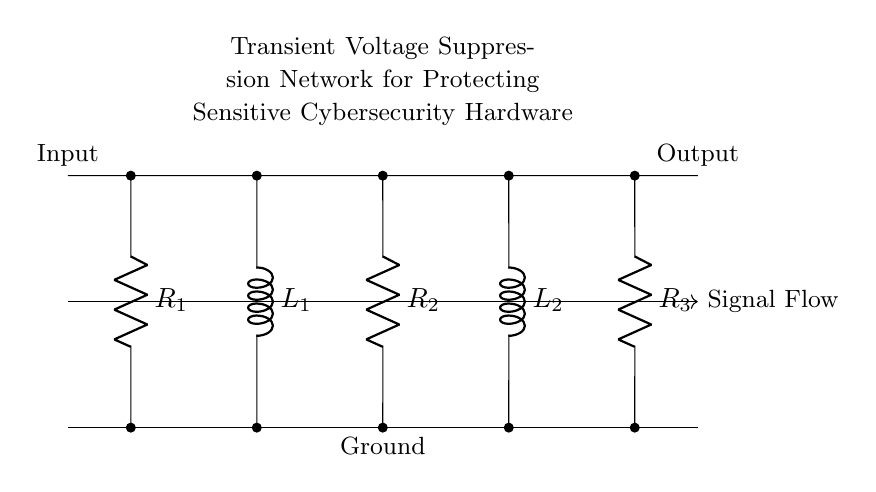What is the total number of resistors in the circuit? There are three resistors indicated by labels R1, R2, and R3 in the circuit diagram. Each is represented by the R symbol followed by a number.
Answer: three What is the total number of inductors in the circuit? The circuit diagram displays two inductors, identified by labels L1 and L2. They are represented by the L symbol followed by a number.
Answer: two What is the purpose of the transient voltage suppression network? The transient voltage suppression network is designed to protect sensitive hardware from voltage spikes and transients that could cause damage.
Answer: protect hardware Which components are connected in series? All components (R1, L1, R2, L2, R3) are connected in series along the same path from input to output, indicating that they share the same current.
Answer: R1, L1, R2, L2, R3 How would adding a capacitor in parallel to the resistors affect transient suppression? Adding a capacitor in parallel would allow for a faster response to voltage spikes, helping to mitigate transients by absorbing excess energy, leading to improved voltage stability across sensitive components.
Answer: improves suppression What is the configuration type of this circuit? The circuit configuration is a series configuration as all the components are arranged consecutively along a single path for current flow, which is characteristic of a series connection.
Answer: series configuration What happens to the voltage across a series resonant circuit at resonance? At resonance, the impedance of the inductors and capacitors cancels out, resulting in maximum current flow and consequently minimal voltage across the resistors, indicating optimal power transfer.
Answer: minimal voltage across resistors 